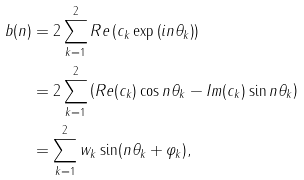<formula> <loc_0><loc_0><loc_500><loc_500>b ( n ) & = 2 \sum _ { k = 1 } ^ { 2 } R e \left ( c _ { k } \exp \left ( i n \theta _ { k } \right ) \right ) \\ & = 2 \sum _ { k = 1 } ^ { 2 } \left ( R e ( c _ { k } ) \cos { n \theta _ { k } } - I m ( c _ { k } ) \sin { n \theta _ { k } } \right ) \\ & = \sum _ { k = 1 } ^ { 2 } w _ { k } \sin ( n \theta _ { k } + \varphi _ { k } ) ,</formula> 